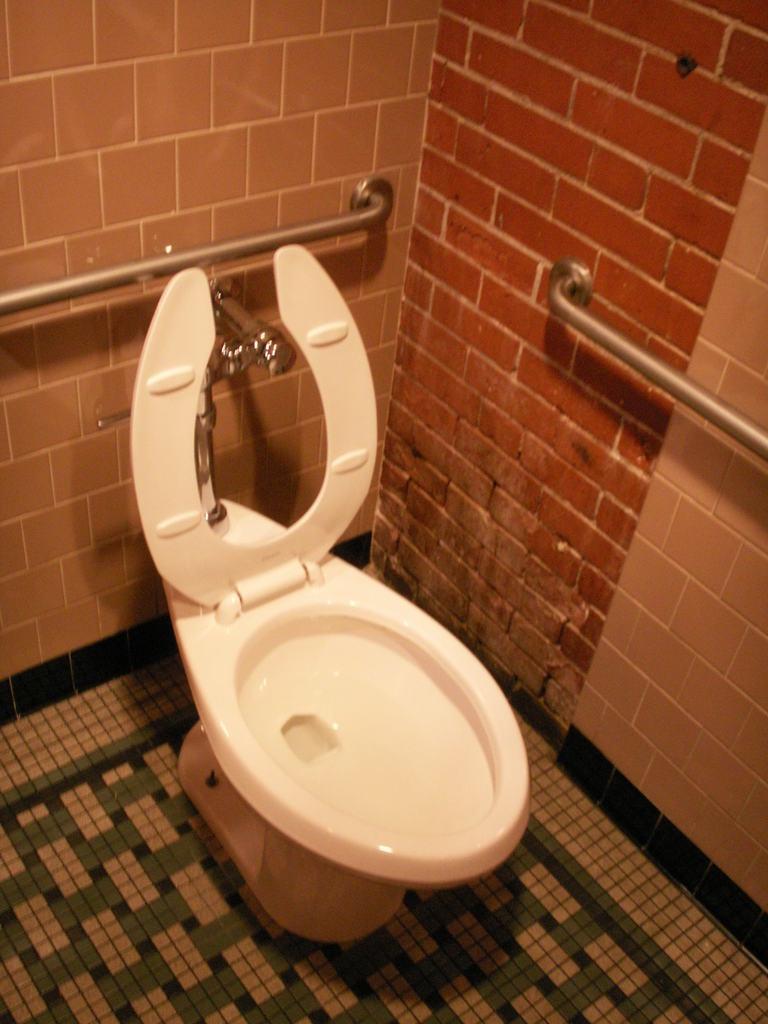In one or two sentences, can you explain what this image depicts? In this image there is a toilet seat on the floor. Few metal rods and a tap are attached to the wall. 